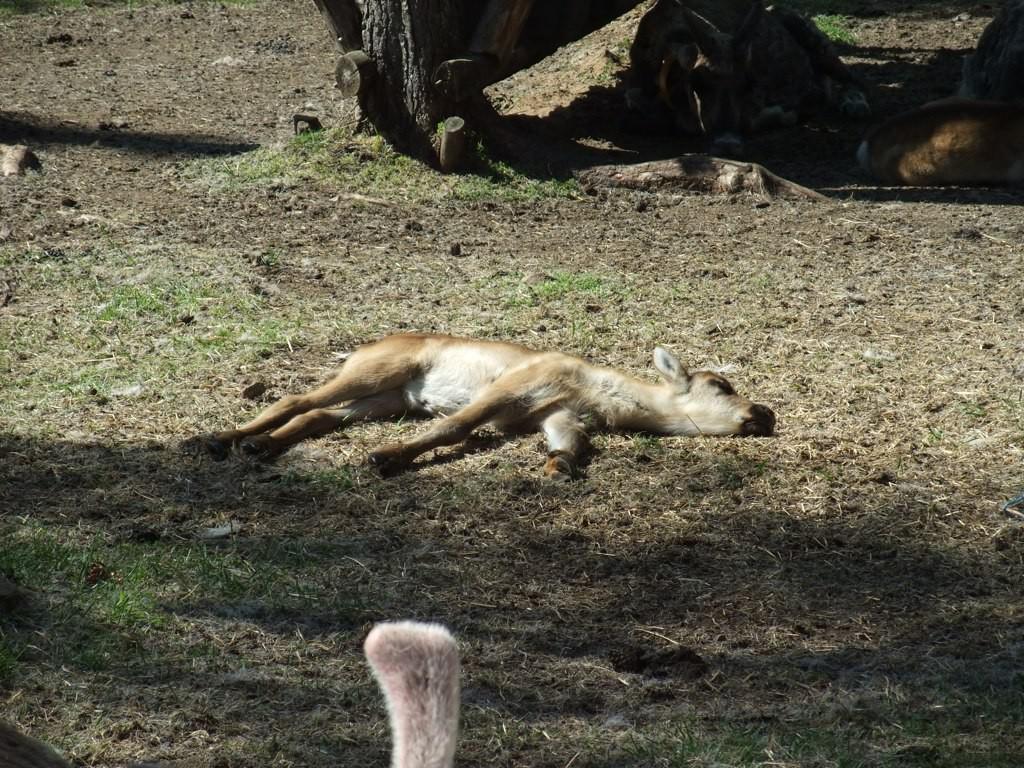Could you give a brief overview of what you see in this image? In this image I can see an animal sleeping on the ground. The animal is in brown color, background I can see grass in green color. 